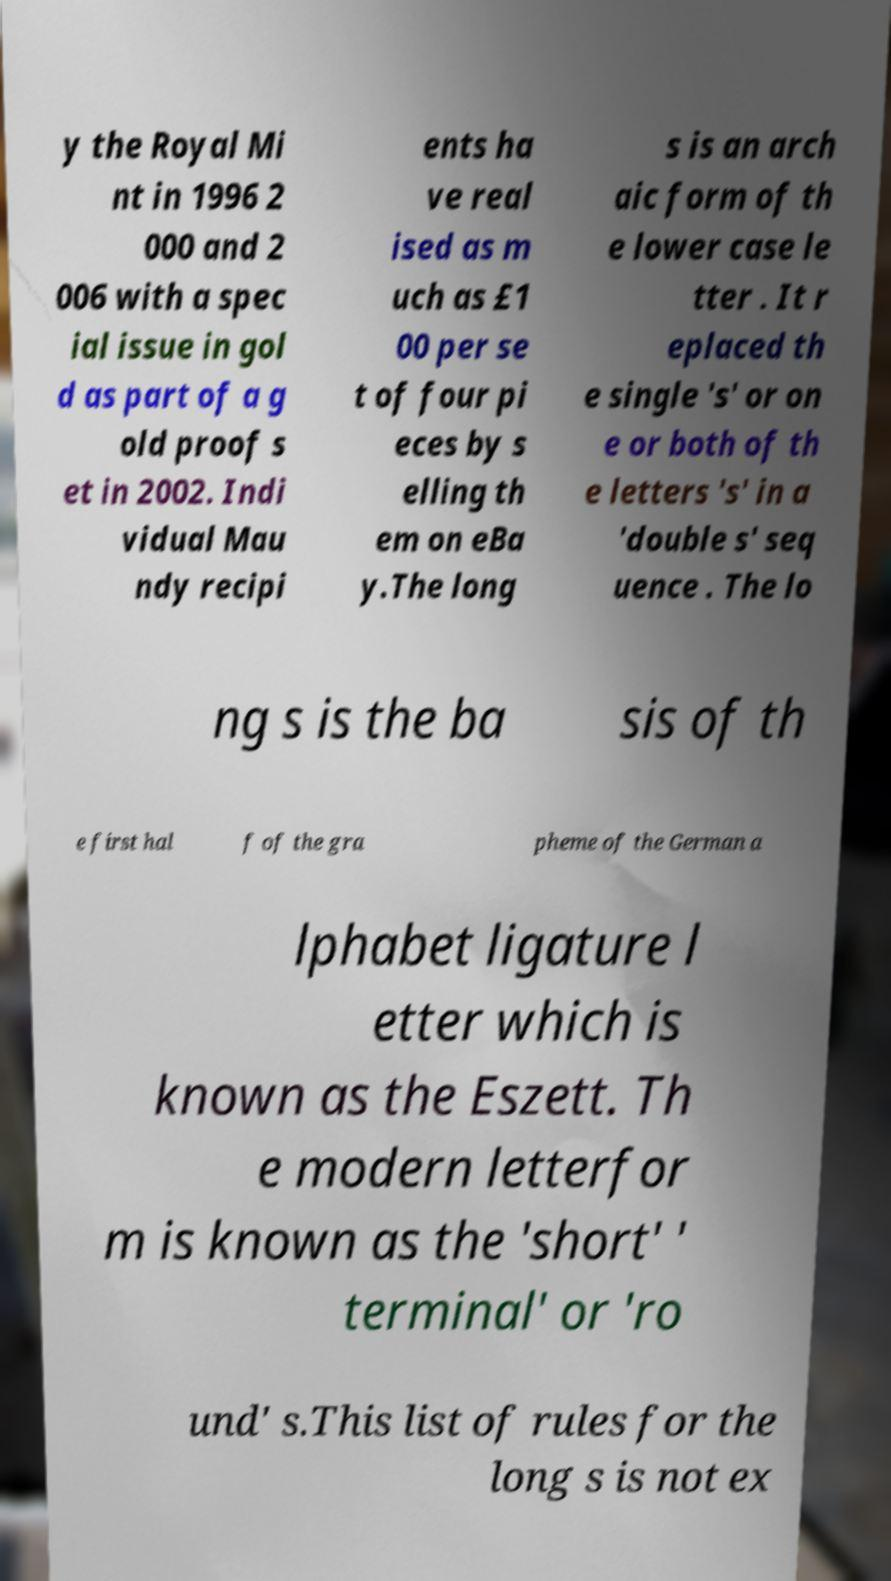I need the written content from this picture converted into text. Can you do that? y the Royal Mi nt in 1996 2 000 and 2 006 with a spec ial issue in gol d as part of a g old proof s et in 2002. Indi vidual Mau ndy recipi ents ha ve real ised as m uch as £1 00 per se t of four pi eces by s elling th em on eBa y.The long s is an arch aic form of th e lower case le tter . It r eplaced th e single 's' or on e or both of th e letters 's' in a 'double s' seq uence . The lo ng s is the ba sis of th e first hal f of the gra pheme of the German a lphabet ligature l etter which is known as the Eszett. Th e modern letterfor m is known as the 'short' ' terminal' or 'ro und' s.This list of rules for the long s is not ex 